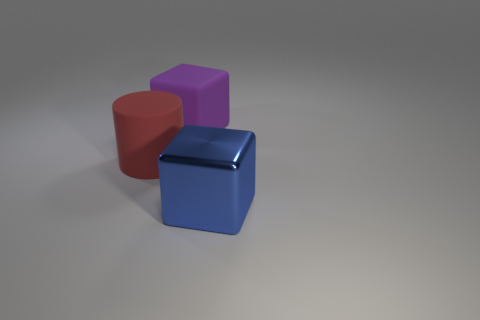How do the surfaces of the three objects compare in sheen and texture? The red rubber cylinder and the purple cube exude a soft, matte finish, indicative of their rubber material, which diffuses light gently. In contrast, the blue metal cube has a reflective, glossy surface that catches the light sharply, highlighting its metallic nature. 